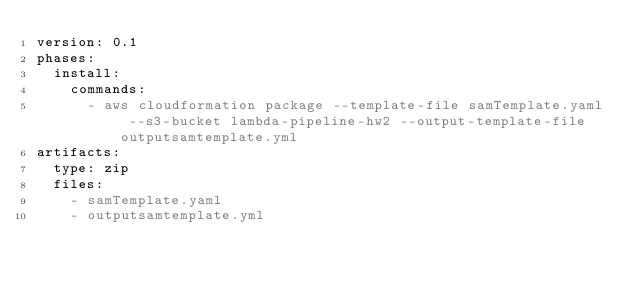<code> <loc_0><loc_0><loc_500><loc_500><_YAML_>version: 0.1
phases:
  install:
    commands:
      - aws cloudformation package --template-file samTemplate.yaml --s3-bucket lambda-pipeline-hw2 --output-template-file outputsamtemplate.yml
artifacts:
  type: zip
  files:
    - samTemplate.yaml
    - outputsamtemplate.yml
</code> 